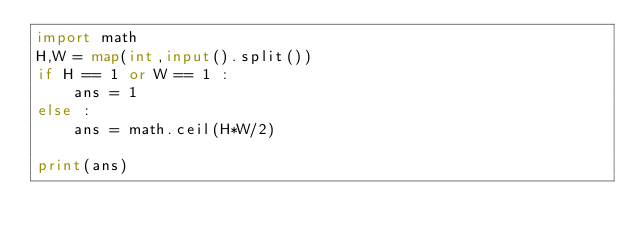<code> <loc_0><loc_0><loc_500><loc_500><_Python_>import math
H,W = map(int,input().split())
if H == 1 or W == 1 :
    ans = 1
else :
    ans = math.ceil(H*W/2)

print(ans)</code> 